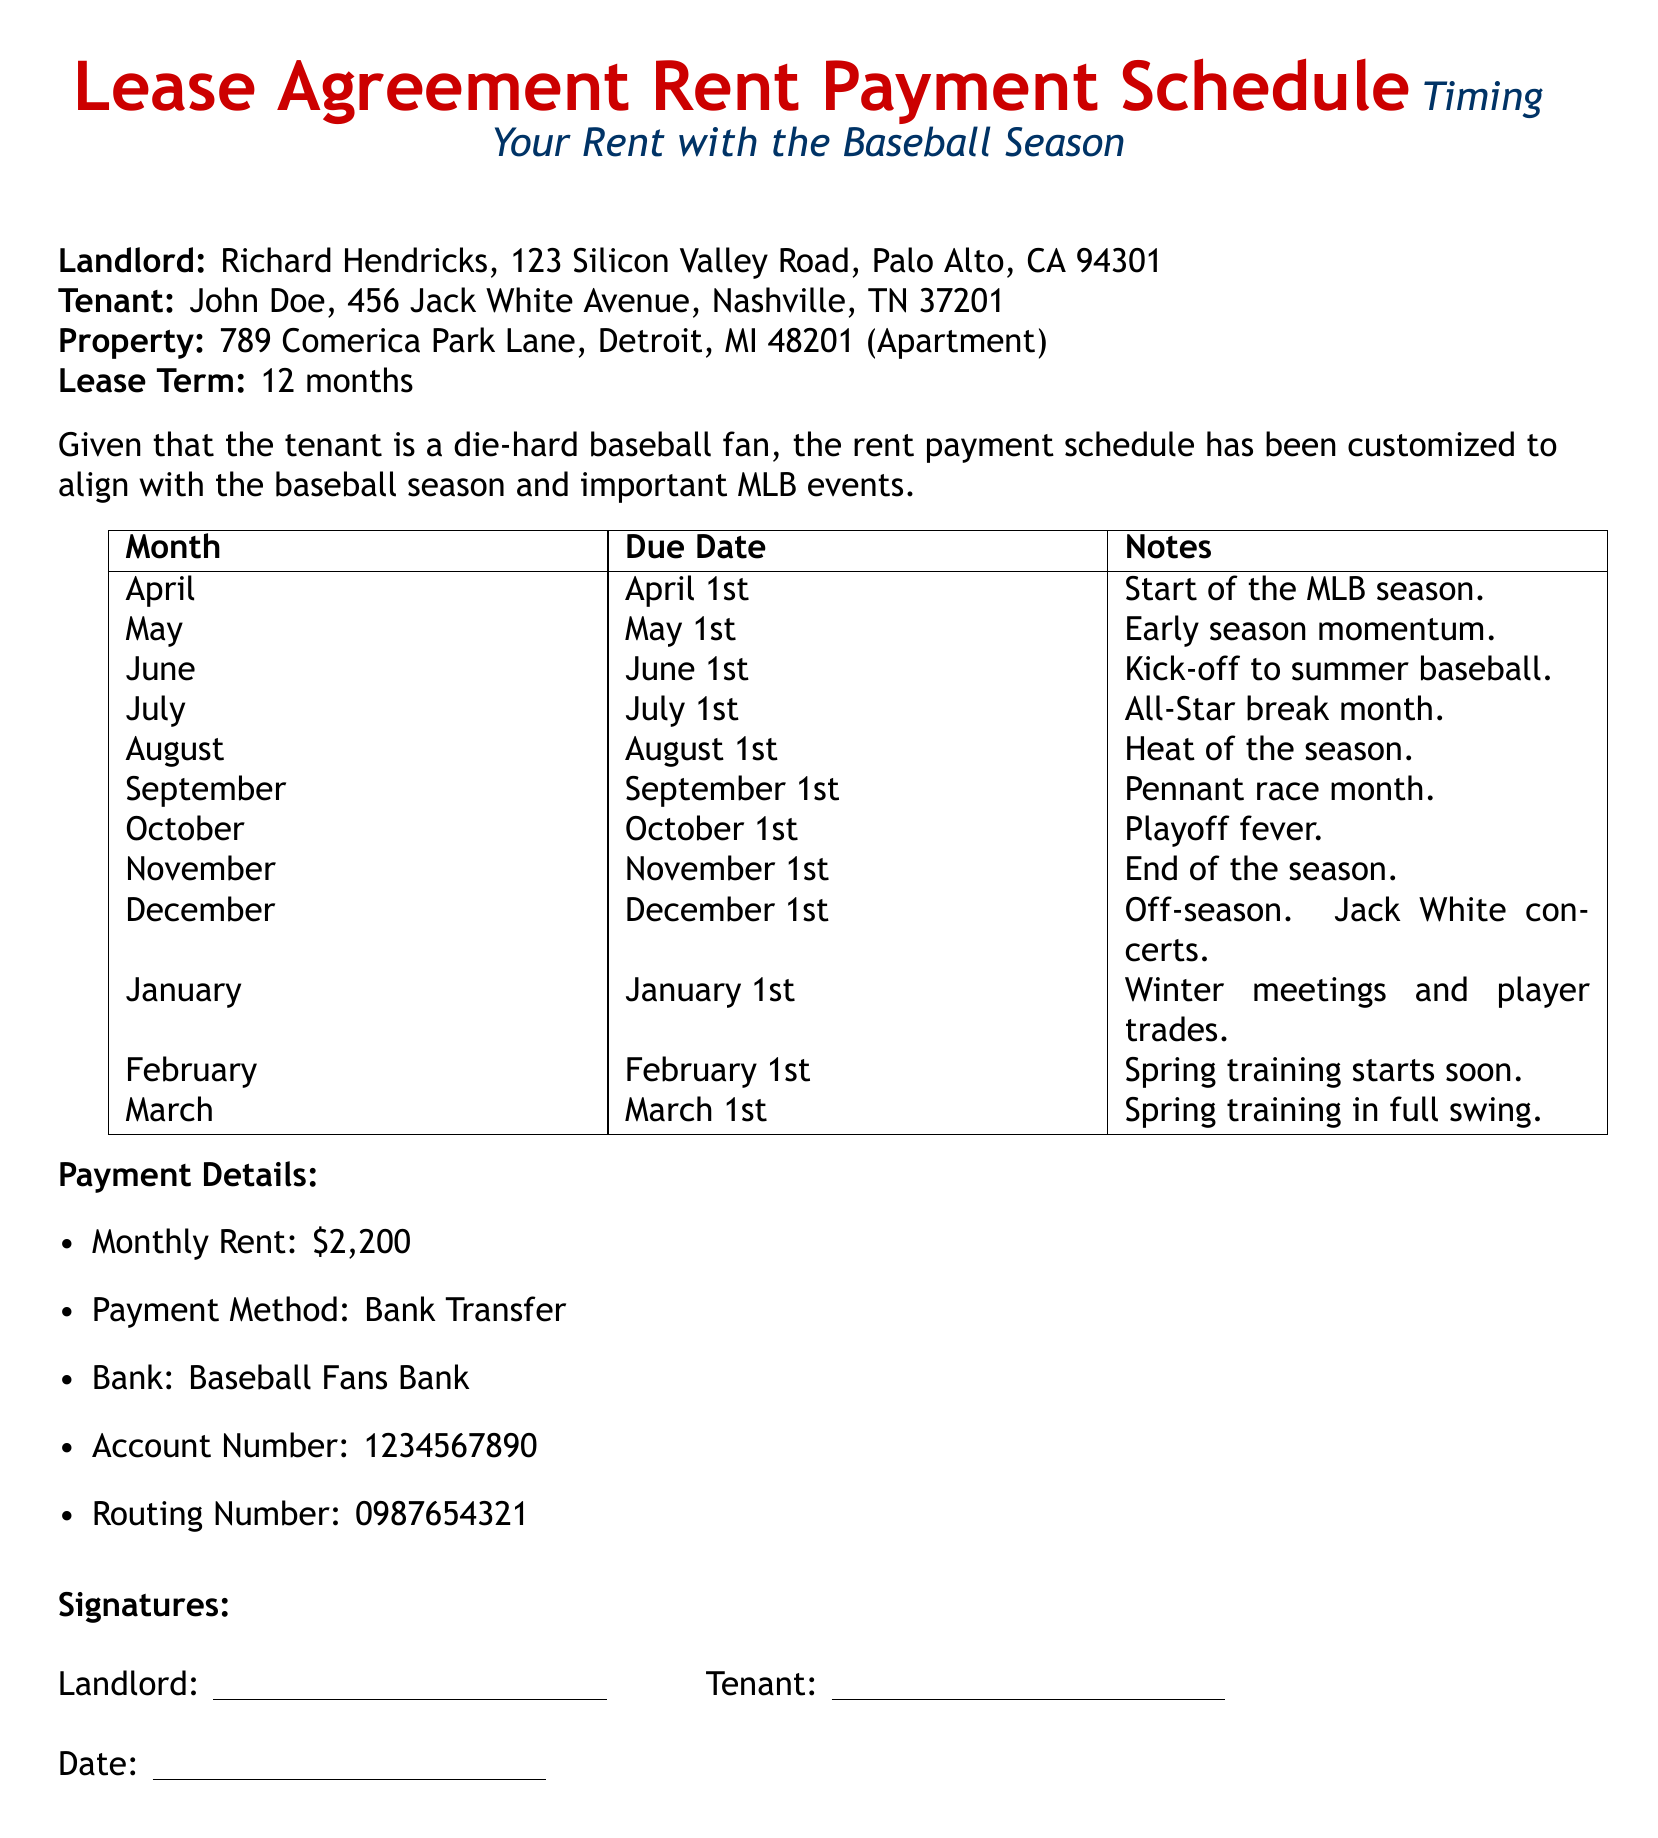What is the tenant's name? The tenant's name is mentioned at the beginning of the document.
Answer: John Doe What is the monthly rent amount? The monthly rent is specified in the Payment Details section.
Answer: $2,200 When is the rent due for the month of July? The due date for July is listed in the Rent Payment Schedule table.
Answer: July 1st What significant baseball event occurs in October? This event is noted in the monthly notes regarding the baseball season.
Answer: Playoff fever What is the landlord's address? The landlord's address is given at the beginning under Landlord.
Answer: 123 Silicon Valley Road, Palo Alto, CA 94301 How many months is the lease term? The lease term is specified clearly in the document.
Answer: 12 months Which month marks the end of the baseball season? The month that signifies the end of the baseball season is indicated in the Rent Payment Schedule.
Answer: November What is the payment method for the rent? The payment method is detailed in the Payment Details section.
Answer: Bank Transfer What does "spring training starts soon" refer to? This phrase is associated with rent due in February according to the payment schedule.
Answer: February 1st 